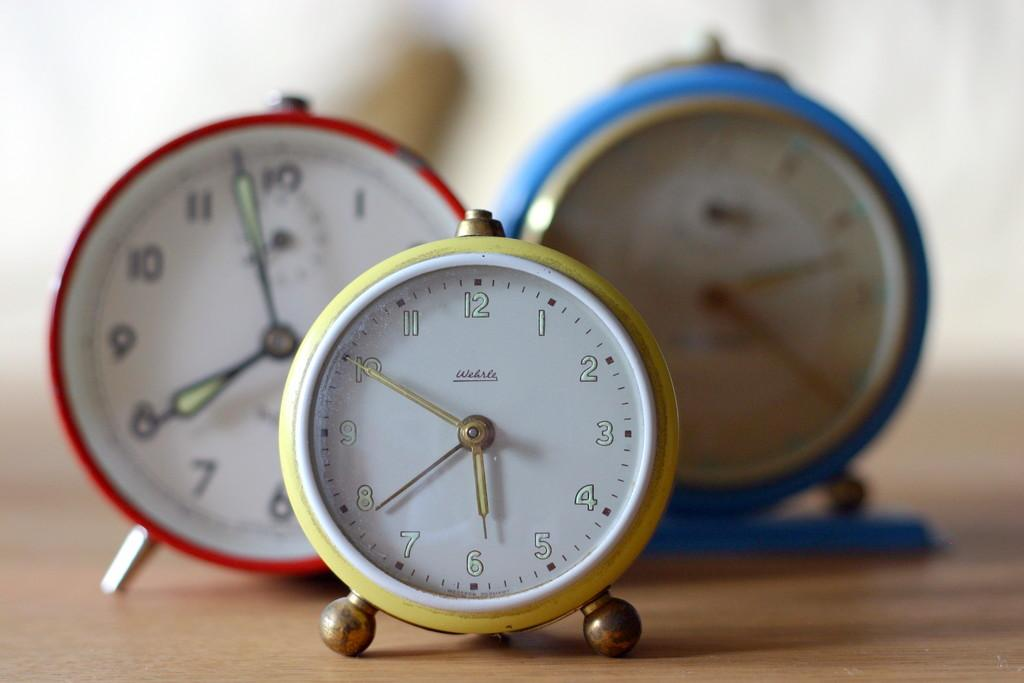Provide a one-sentence caption for the provided image. Three round alarm clocks showing 7:57, 5:50, and 2:20. 